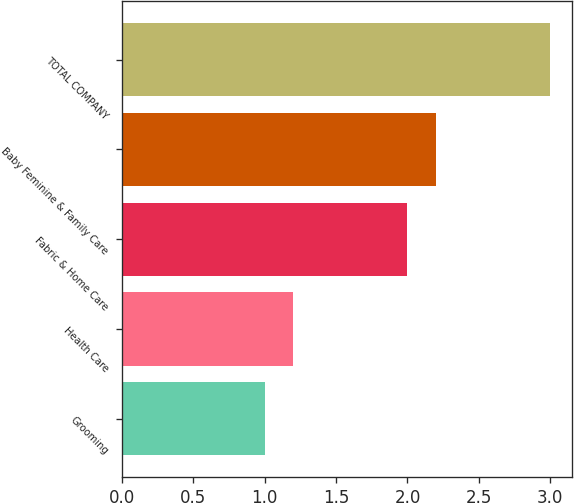Convert chart. <chart><loc_0><loc_0><loc_500><loc_500><bar_chart><fcel>Grooming<fcel>Health Care<fcel>Fabric & Home Care<fcel>Baby Feminine & Family Care<fcel>TOTAL COMPANY<nl><fcel>1<fcel>1.2<fcel>2<fcel>2.2<fcel>3<nl></chart> 